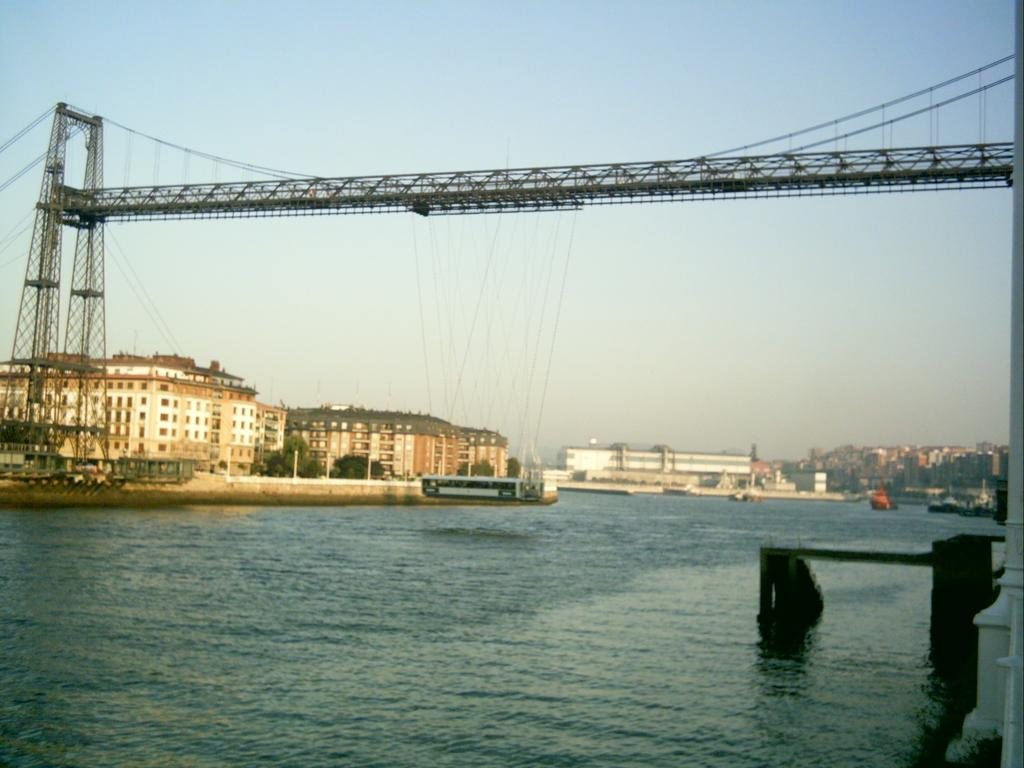What is the primary element in the image? There is water in the image. What can be seen floating on the water? There are objects floating on the water. What type of structure is present in the image? There is a bridge in the image. What type of buildings can be seen in the image? There are houses in the image. What type of vegetation is present in the image? There are trees in the image. What type of vertical structures are present in the image? There are poles in the image. What part of the natural environment is visible in the image? The sky is visible in the image. What type of respect can be seen on the page in the image? There is no page or respect present in the image; it features water, floating objects, a bridge, houses, trees, poles, and the sky. 